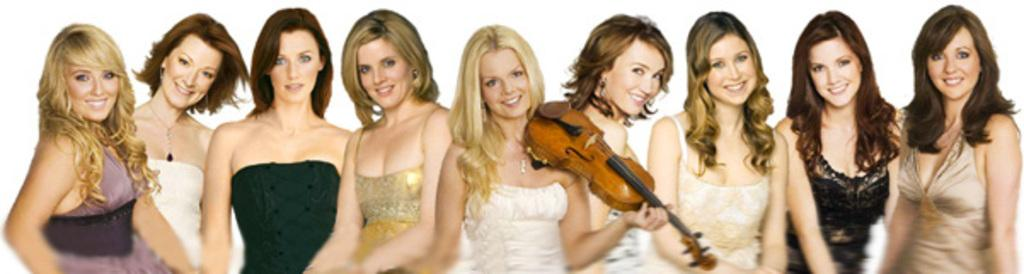What is the main subject of the image? The main subject of the image is a group of people. Can you describe the woman in the image? The woman is standing in the middle of the group. What is the woman holding in the image? The woman is holding a guitar. What type of fight can be seen happening between the girls in the image? There are no girls or fights present in the image; it features a group of people with a woman holding a guitar. 